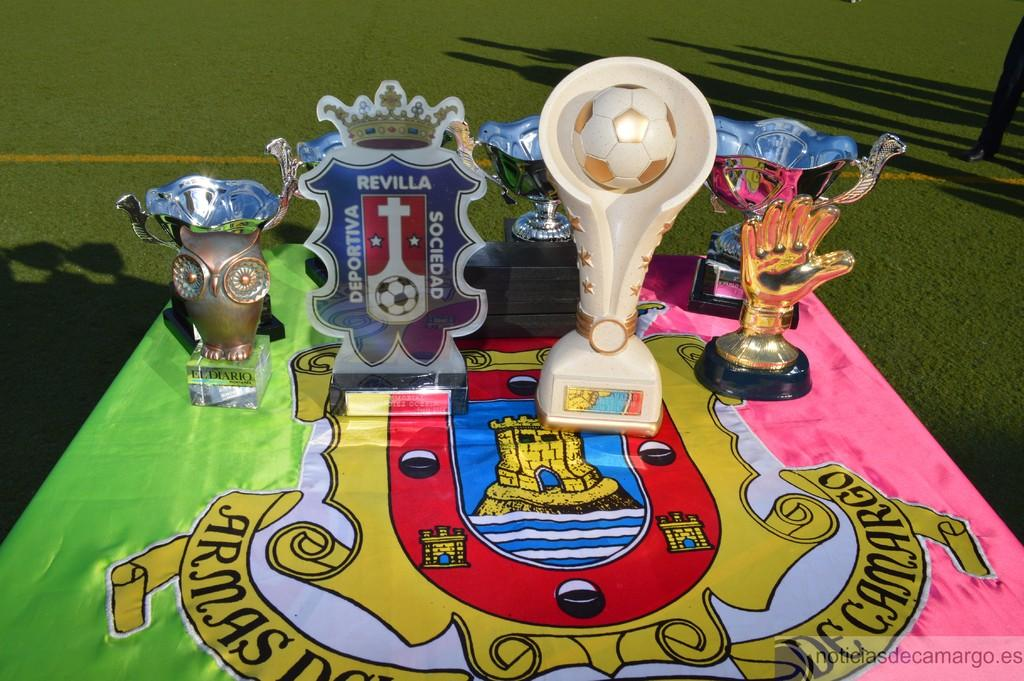<image>
Offer a succinct explanation of the picture presented. A coat of arms type design has the words Sociedad, Deportiva and Revilla on it. 